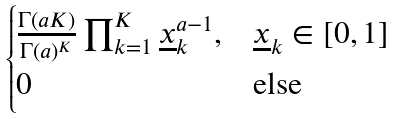Convert formula to latex. <formula><loc_0><loc_0><loc_500><loc_500>\begin{cases} \frac { \Gamma ( a K ) } { \Gamma ( a ) ^ { K } } \prod _ { k = 1 } ^ { K } \underline { x } _ { k } ^ { a - 1 } , & \underline { x } _ { k } \in [ 0 , 1 ] \\ 0 & \text {else} \end{cases}</formula> 